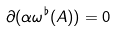Convert formula to latex. <formula><loc_0><loc_0><loc_500><loc_500>\partial ( \alpha \omega ^ { \flat } ( A ) ) = 0</formula> 